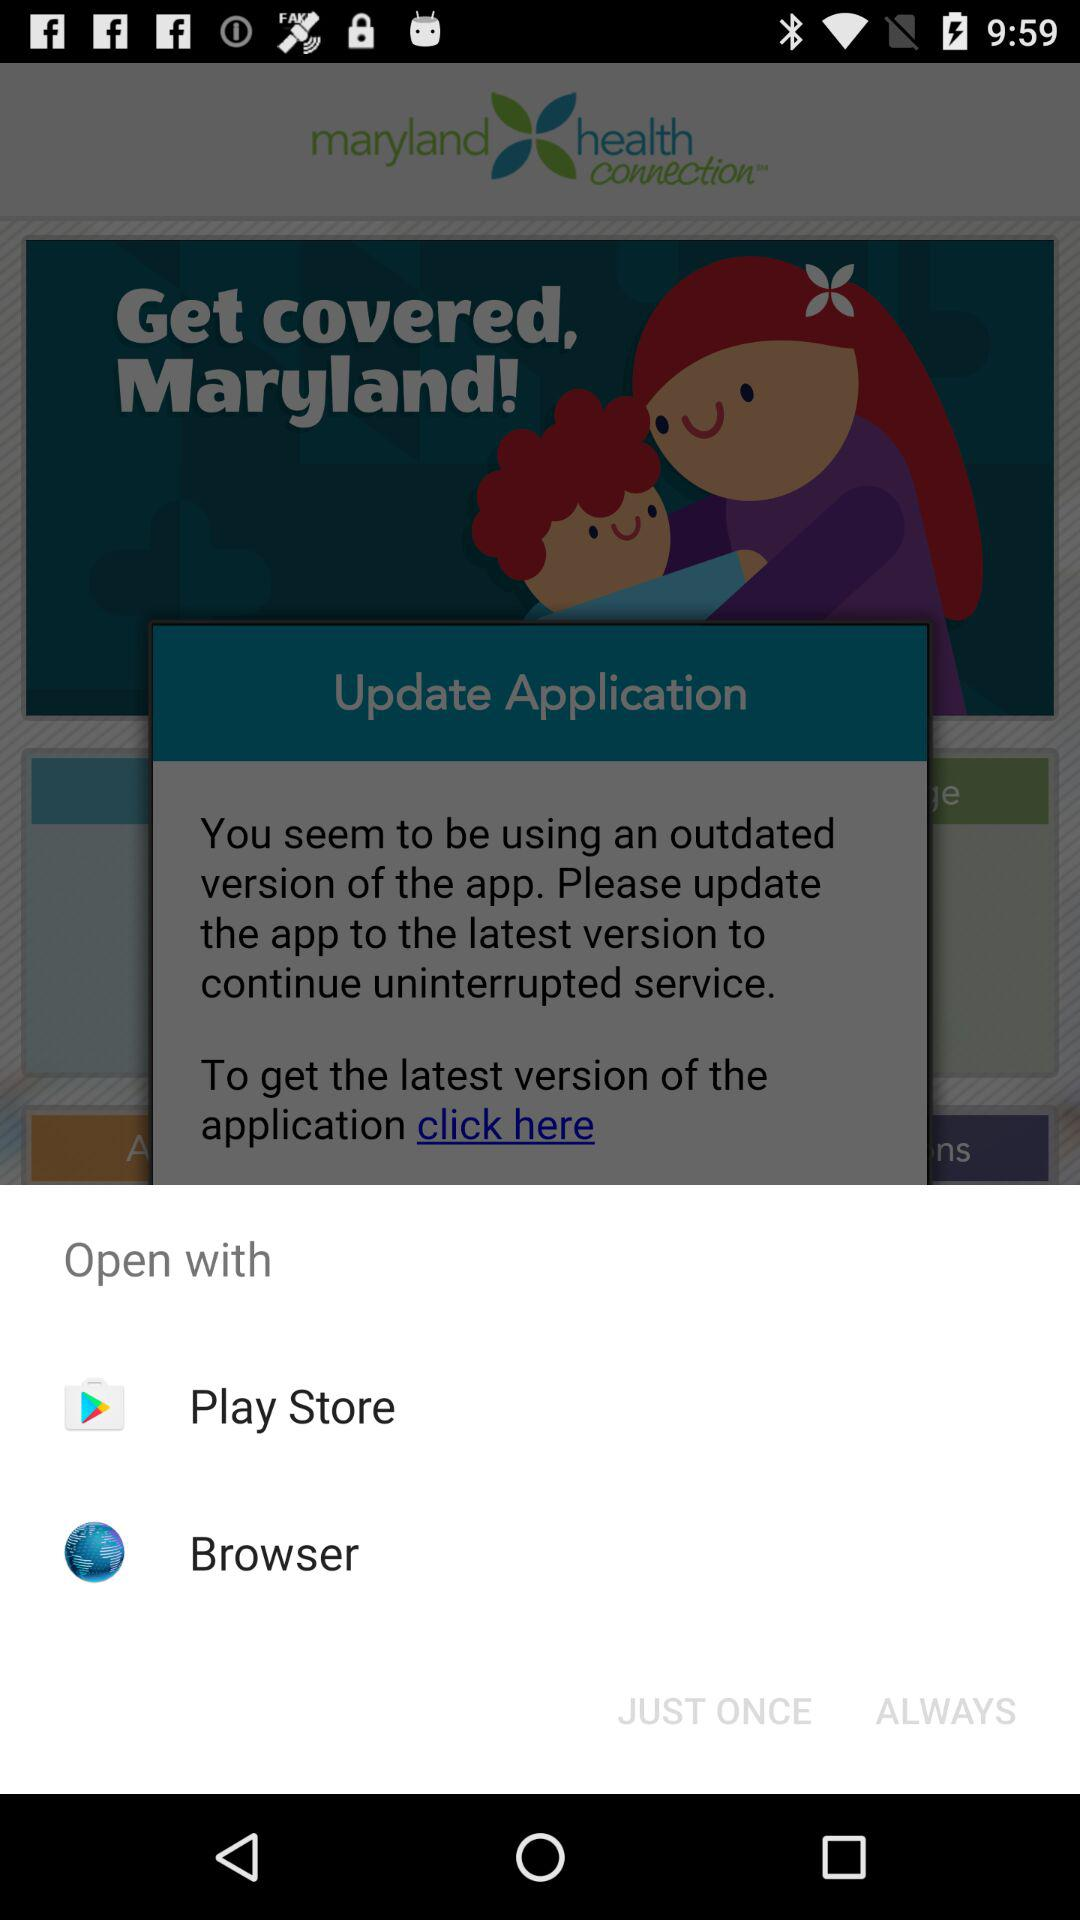Which options are given to open it? The options are "Play Store" and "Browser". 